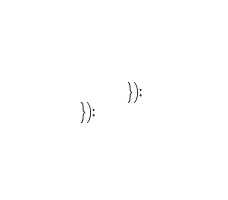Convert code to text. <code><loc_0><loc_0><loc_500><loc_500><_JavaScript_>
        }); 
});  </code> 